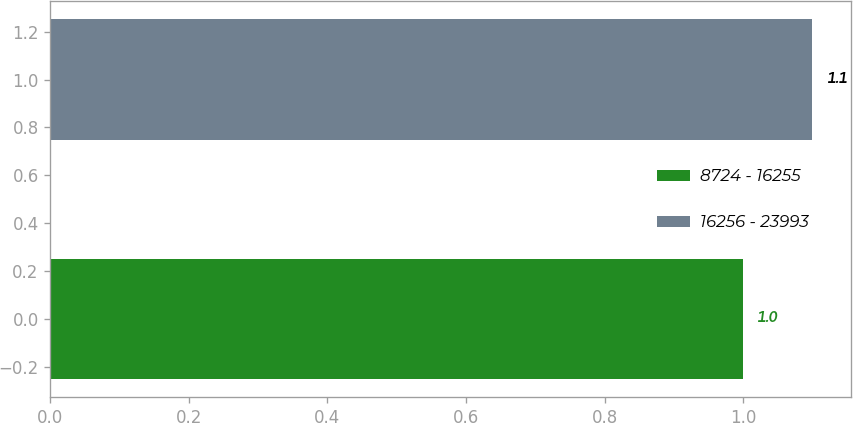<chart> <loc_0><loc_0><loc_500><loc_500><bar_chart><fcel>8724 - 16255<fcel>16256 - 23993<nl><fcel>1<fcel>1.1<nl></chart> 